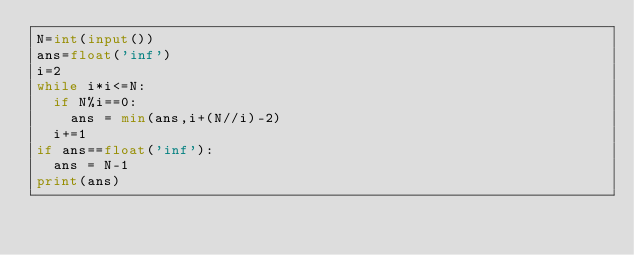Convert code to text. <code><loc_0><loc_0><loc_500><loc_500><_Python_>N=int(input())
ans=float('inf')
i=2
while i*i<=N:
  if N%i==0:
    ans = min(ans,i+(N//i)-2)
  i+=1
if ans==float('inf'):
  ans = N-1
print(ans)</code> 